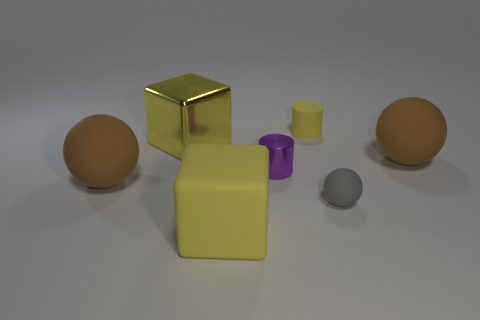There is a big cube that is in front of the small matte ball; what is its color?
Provide a short and direct response. Yellow. Are there more big yellow matte objects that are behind the small purple object than large shiny objects?
Make the answer very short. No. How many other things are the same size as the purple cylinder?
Your answer should be very brief. 2. What number of tiny rubber cylinders are in front of the small matte cylinder?
Your answer should be very brief. 0. Are there the same number of tiny gray things that are behind the purple metal object and rubber cylinders that are in front of the yellow metal thing?
Offer a very short reply. Yes. There is a yellow object that is the same shape as the purple object; what is its size?
Provide a succinct answer. Small. There is a yellow object that is right of the purple cylinder; what is its shape?
Offer a terse response. Cylinder. Is the big yellow thing that is in front of the gray rubber thing made of the same material as the large brown ball that is on the left side of the tiny yellow cylinder?
Offer a very short reply. Yes. What shape is the gray matte thing?
Keep it short and to the point. Sphere. Is the number of yellow matte things to the right of the rubber cylinder the same as the number of purple metal cylinders?
Offer a very short reply. No. 